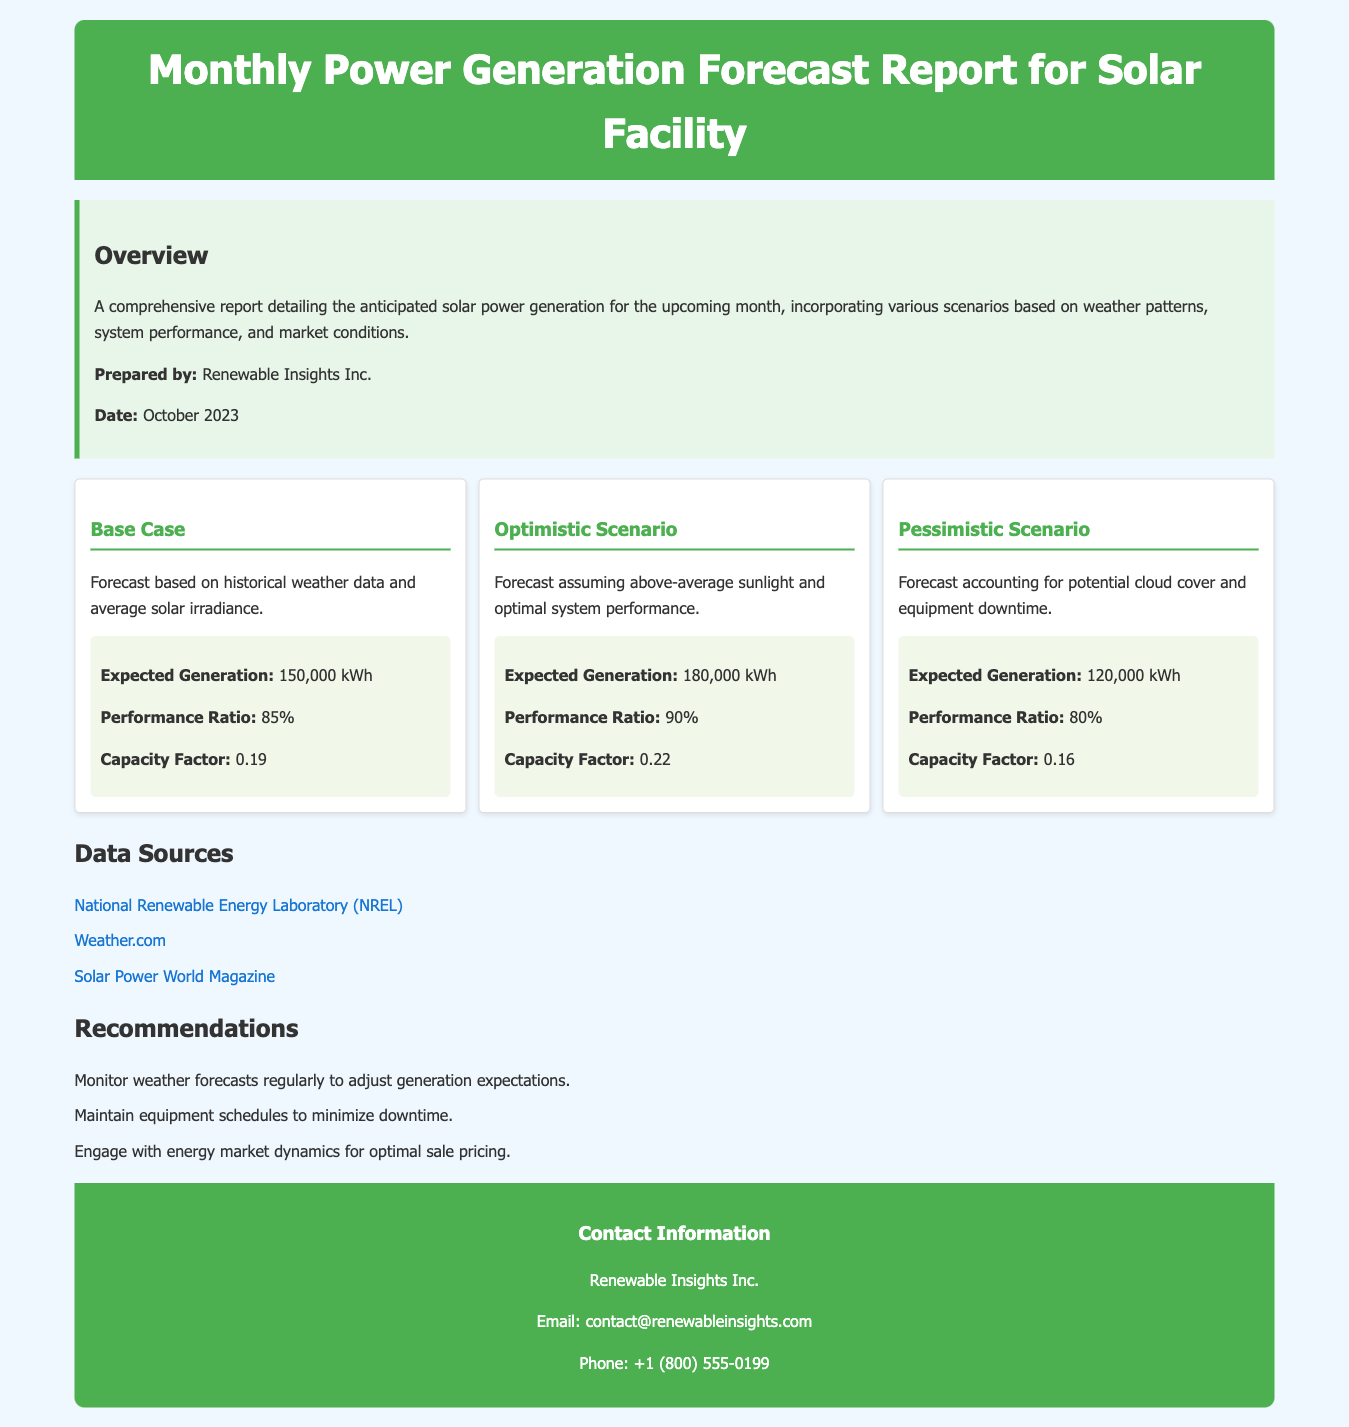what is the expected generation in the optimistic scenario? The expected generation in the optimistic scenario is listed in the document as 180,000 kWh.
Answer: 180,000 kWh what is the performance ratio for the base case? The performance ratio for the base case is provided as 85%.
Answer: 85% when was the report prepared? The report preparation date is mentioned as October 2023.
Answer: October 2023 what is the pessimistic scenario's expected generation? The expected generation for the pessimistic scenario is stated as 120,000 kWh.
Answer: 120,000 kWh which organization prepared the report? The report was prepared by Renewable Insights Inc.
Answer: Renewable Insights Inc what is one recommendation from the report? Recommendations in the document include monitoring weather forecasts regularly.
Answer: Monitor weather forecasts regularly what is the capacity factor for the optimistic scenario? The document specifies the capacity factor for the optimistic scenario as 0.22.
Answer: 0.22 name one data source mentioned in the report. A data source listed in the document is the National Renewable Energy Laboratory.
Answer: National Renewable Energy Laboratory 